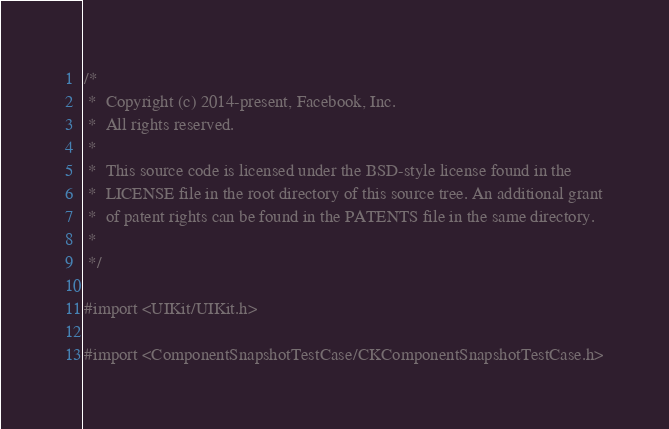Convert code to text. <code><loc_0><loc_0><loc_500><loc_500><_ObjectiveC_>/*
 *  Copyright (c) 2014-present, Facebook, Inc.
 *  All rights reserved.
 *
 *  This source code is licensed under the BSD-style license found in the
 *  LICENSE file in the root directory of this source tree. An additional grant
 *  of patent rights can be found in the PATENTS file in the same directory.
 *
 */

#import <UIKit/UIKit.h>

#import <ComponentSnapshotTestCase/CKComponentSnapshotTestCase.h>
</code> 